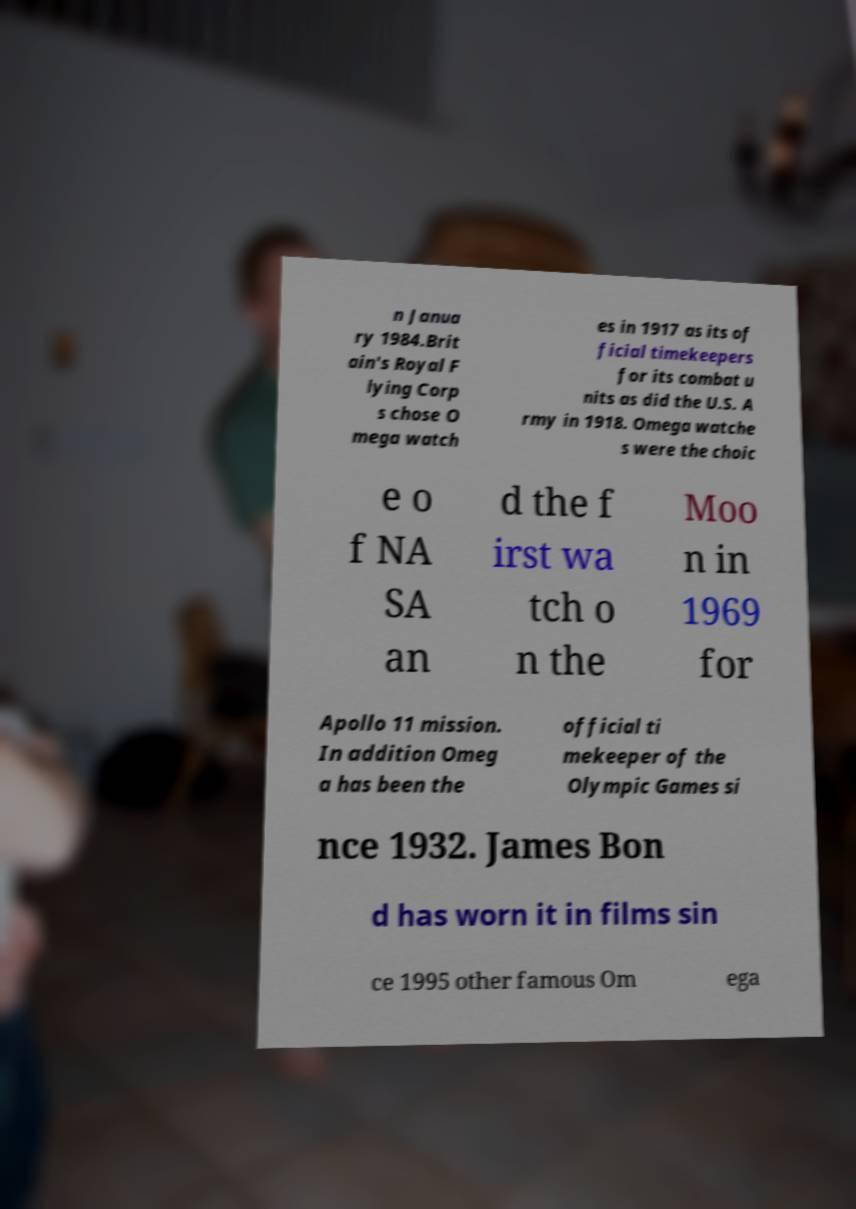Can you read and provide the text displayed in the image?This photo seems to have some interesting text. Can you extract and type it out for me? n Janua ry 1984.Brit ain's Royal F lying Corp s chose O mega watch es in 1917 as its of ficial timekeepers for its combat u nits as did the U.S. A rmy in 1918. Omega watche s were the choic e o f NA SA an d the f irst wa tch o n the Moo n in 1969 for Apollo 11 mission. In addition Omeg a has been the official ti mekeeper of the Olympic Games si nce 1932. James Bon d has worn it in films sin ce 1995 other famous Om ega 